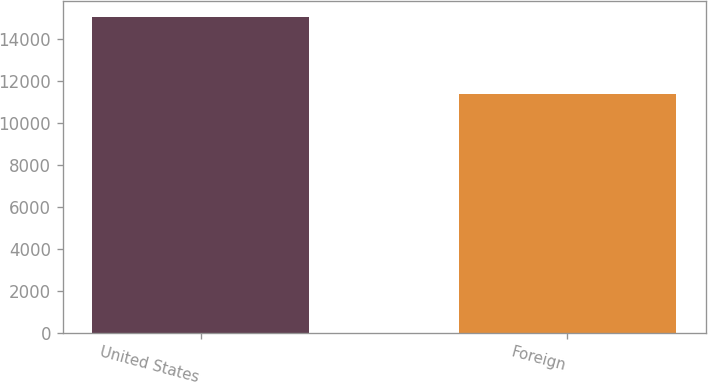<chart> <loc_0><loc_0><loc_500><loc_500><bar_chart><fcel>United States<fcel>Foreign<nl><fcel>15029<fcel>11367<nl></chart> 